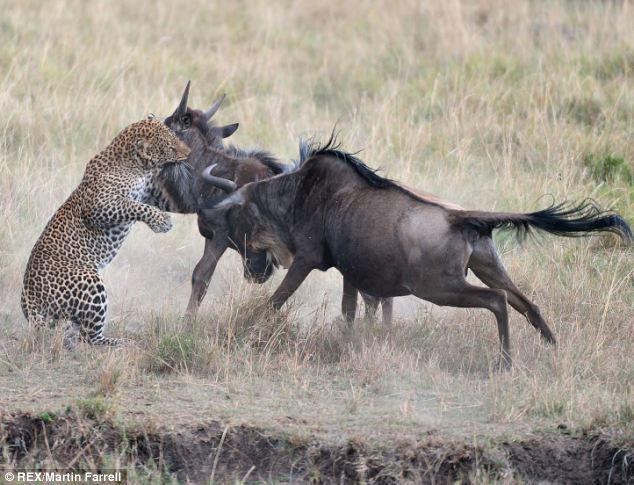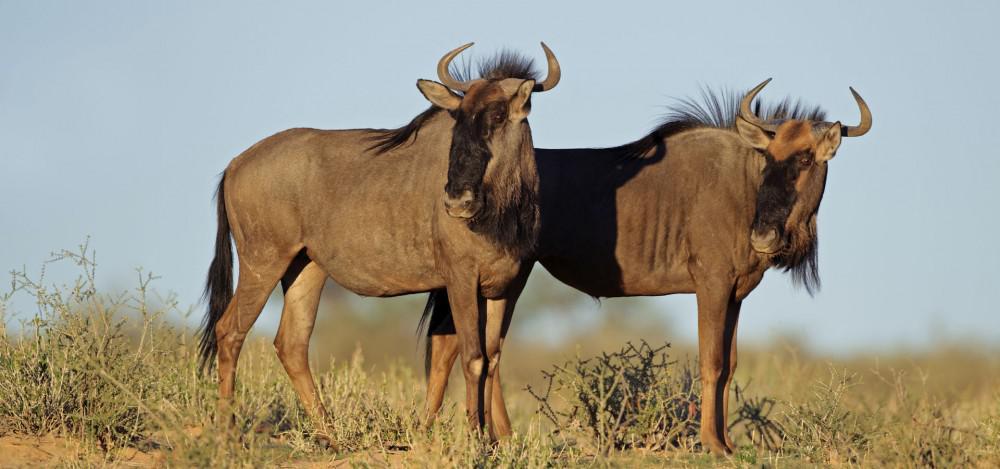The first image is the image on the left, the second image is the image on the right. Analyze the images presented: Is the assertion "There are more hooved, horned animals on the right than on the left." valid? Answer yes or no. No. The first image is the image on the left, the second image is the image on the right. Evaluate the accuracy of this statement regarding the images: "There are exactly two animals in the image on the left.". Is it true? Answer yes or no. No. 